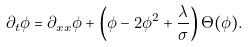Convert formula to latex. <formula><loc_0><loc_0><loc_500><loc_500>\partial _ { t } \phi = \partial _ { x x } \phi + \left ( \phi - 2 \phi ^ { 2 } + \frac { \lambda } { \sigma } \right ) \Theta ( \phi ) .</formula> 